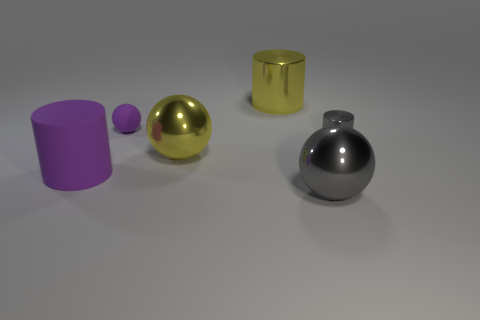Are there more large cylinders that are right of the small metallic object than purple spheres that are right of the purple matte sphere?
Offer a very short reply. No. There is a object that is the same color as the tiny matte ball; what material is it?
Your response must be concise. Rubber. Are there any other things that are the same shape as the big rubber object?
Provide a succinct answer. Yes. What is the thing that is behind the big purple rubber cylinder and in front of the gray shiny cylinder made of?
Ensure brevity in your answer.  Metal. Is the material of the gray cylinder the same as the gray ball that is in front of the large purple thing?
Your answer should be compact. Yes. What number of things are large gray things or gray objects in front of the small gray metallic cylinder?
Ensure brevity in your answer.  1. Is the size of the rubber thing that is in front of the small purple rubber object the same as the gray metal object that is to the left of the tiny shiny cylinder?
Provide a succinct answer. Yes. What number of other objects are there of the same color as the large matte cylinder?
Give a very brief answer. 1. There is a purple sphere; is its size the same as the purple matte thing on the left side of the small purple sphere?
Offer a very short reply. No. How big is the cylinder right of the big gray metallic sphere that is in front of the rubber cylinder?
Offer a terse response. Small. 